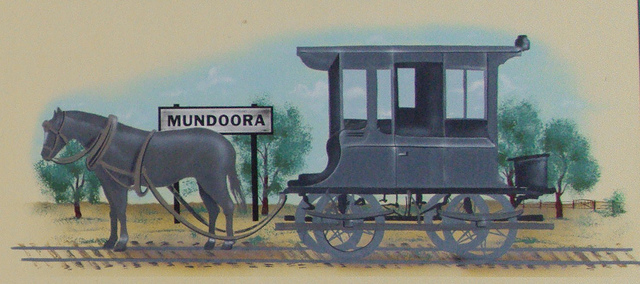Identify the text contained in this image. MUNDOORA 